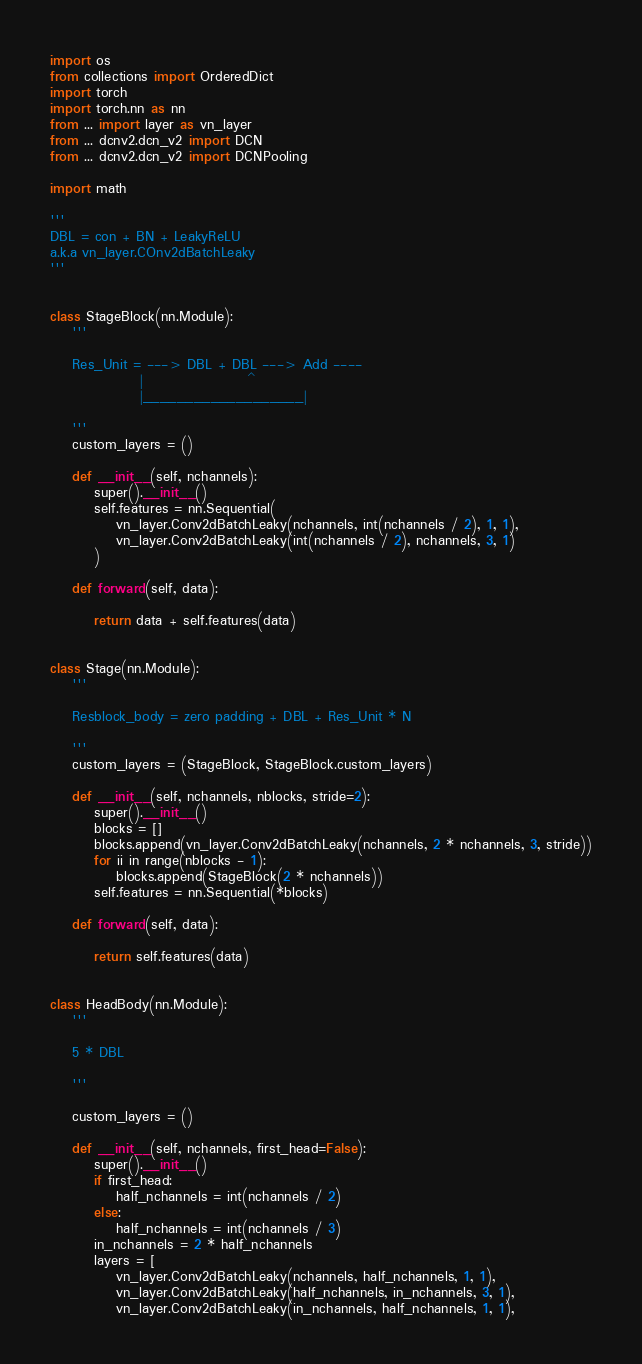Convert code to text. <code><loc_0><loc_0><loc_500><loc_500><_Python_>import os
from collections import OrderedDict
import torch
import torch.nn as nn
from ... import layer as vn_layer
from ... dcnv2.dcn_v2 import DCN
from ... dcnv2.dcn_v2 import DCNPooling

import math

'''
DBL = con + BN + LeakyReLU
a.k.a vn_layer.COnv2dBatchLeaky
'''


class StageBlock(nn.Module):
    '''

    Res_Unit = ---> DBL + DBL ---> Add ----
                |                   ^
                |___________________|

    '''
    custom_layers = ()

    def __init__(self, nchannels):
        super().__init__()
        self.features = nn.Sequential(
            vn_layer.Conv2dBatchLeaky(nchannels, int(nchannels / 2), 1, 1),
            vn_layer.Conv2dBatchLeaky(int(nchannels / 2), nchannels, 3, 1)
        )

    def forward(self, data):

        return data + self.features(data)


class Stage(nn.Module):
    '''

    Resblock_body = zero padding + DBL + Res_Unit * N

    '''
    custom_layers = (StageBlock, StageBlock.custom_layers)

    def __init__(self, nchannels, nblocks, stride=2):
        super().__init__()
        blocks = []
        blocks.append(vn_layer.Conv2dBatchLeaky(nchannels, 2 * nchannels, 3, stride))
        for ii in range(nblocks - 1):
            blocks.append(StageBlock(2 * nchannels))
        self.features = nn.Sequential(*blocks)

    def forward(self, data):

        return self.features(data)


class HeadBody(nn.Module):
    '''

    5 * DBL

    '''

    custom_layers = ()

    def __init__(self, nchannels, first_head=False):
        super().__init__()
        if first_head:
            half_nchannels = int(nchannels / 2)
        else:
            half_nchannels = int(nchannels / 3)
        in_nchannels = 2 * half_nchannels
        layers = [
            vn_layer.Conv2dBatchLeaky(nchannels, half_nchannels, 1, 1),
            vn_layer.Conv2dBatchLeaky(half_nchannels, in_nchannels, 3, 1),
            vn_layer.Conv2dBatchLeaky(in_nchannels, half_nchannels, 1, 1),</code> 